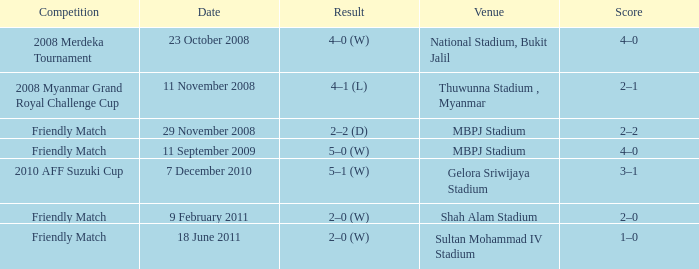What is the Venue of the Competition with a Result of 2–2 (d)? MBPJ Stadium. 